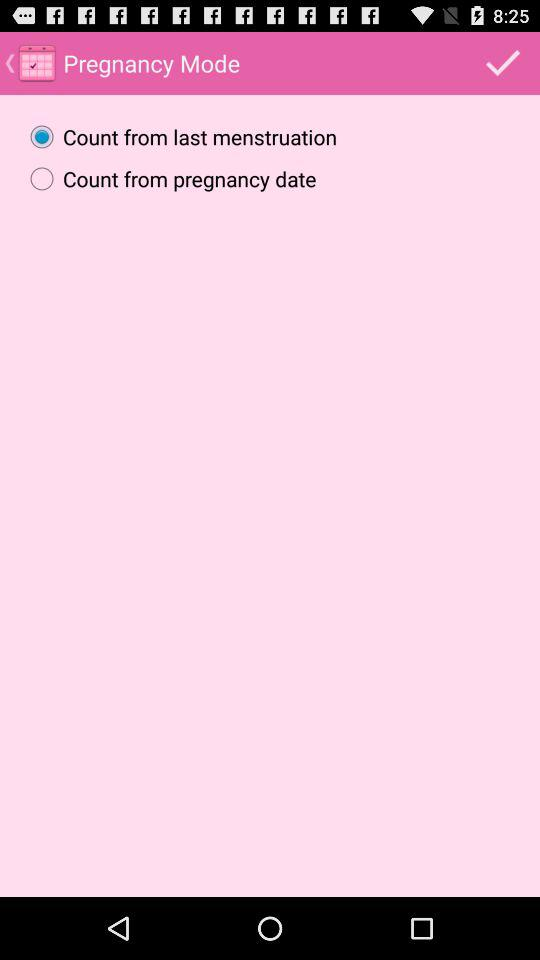What's the selected option in "Pregnancy Mode"? The selected option is "Count from last menstruation". 